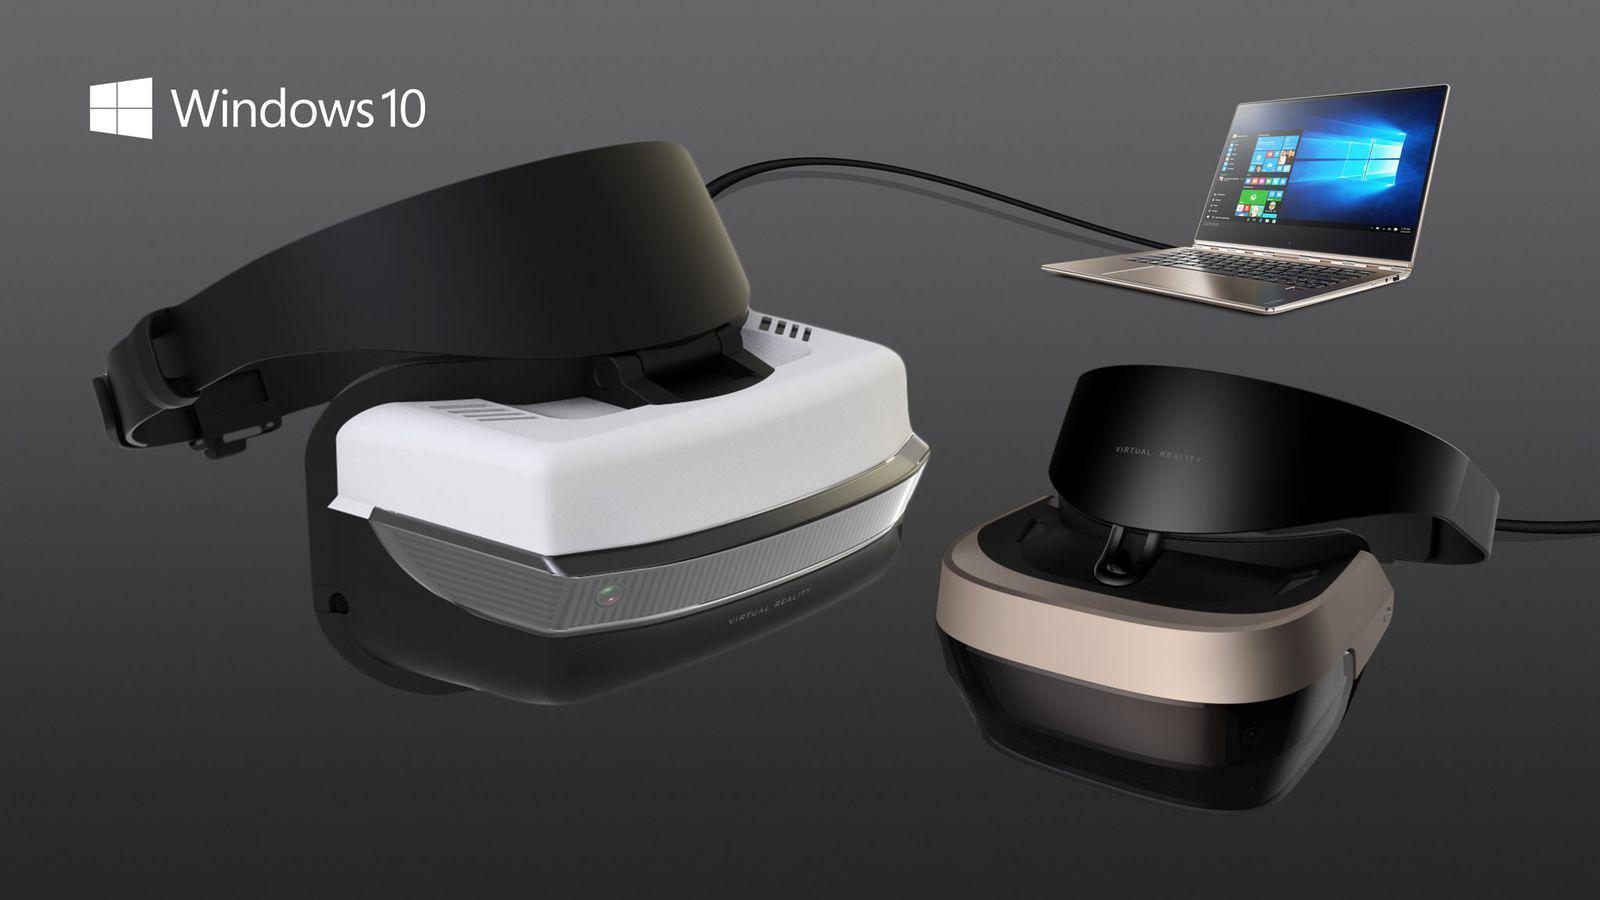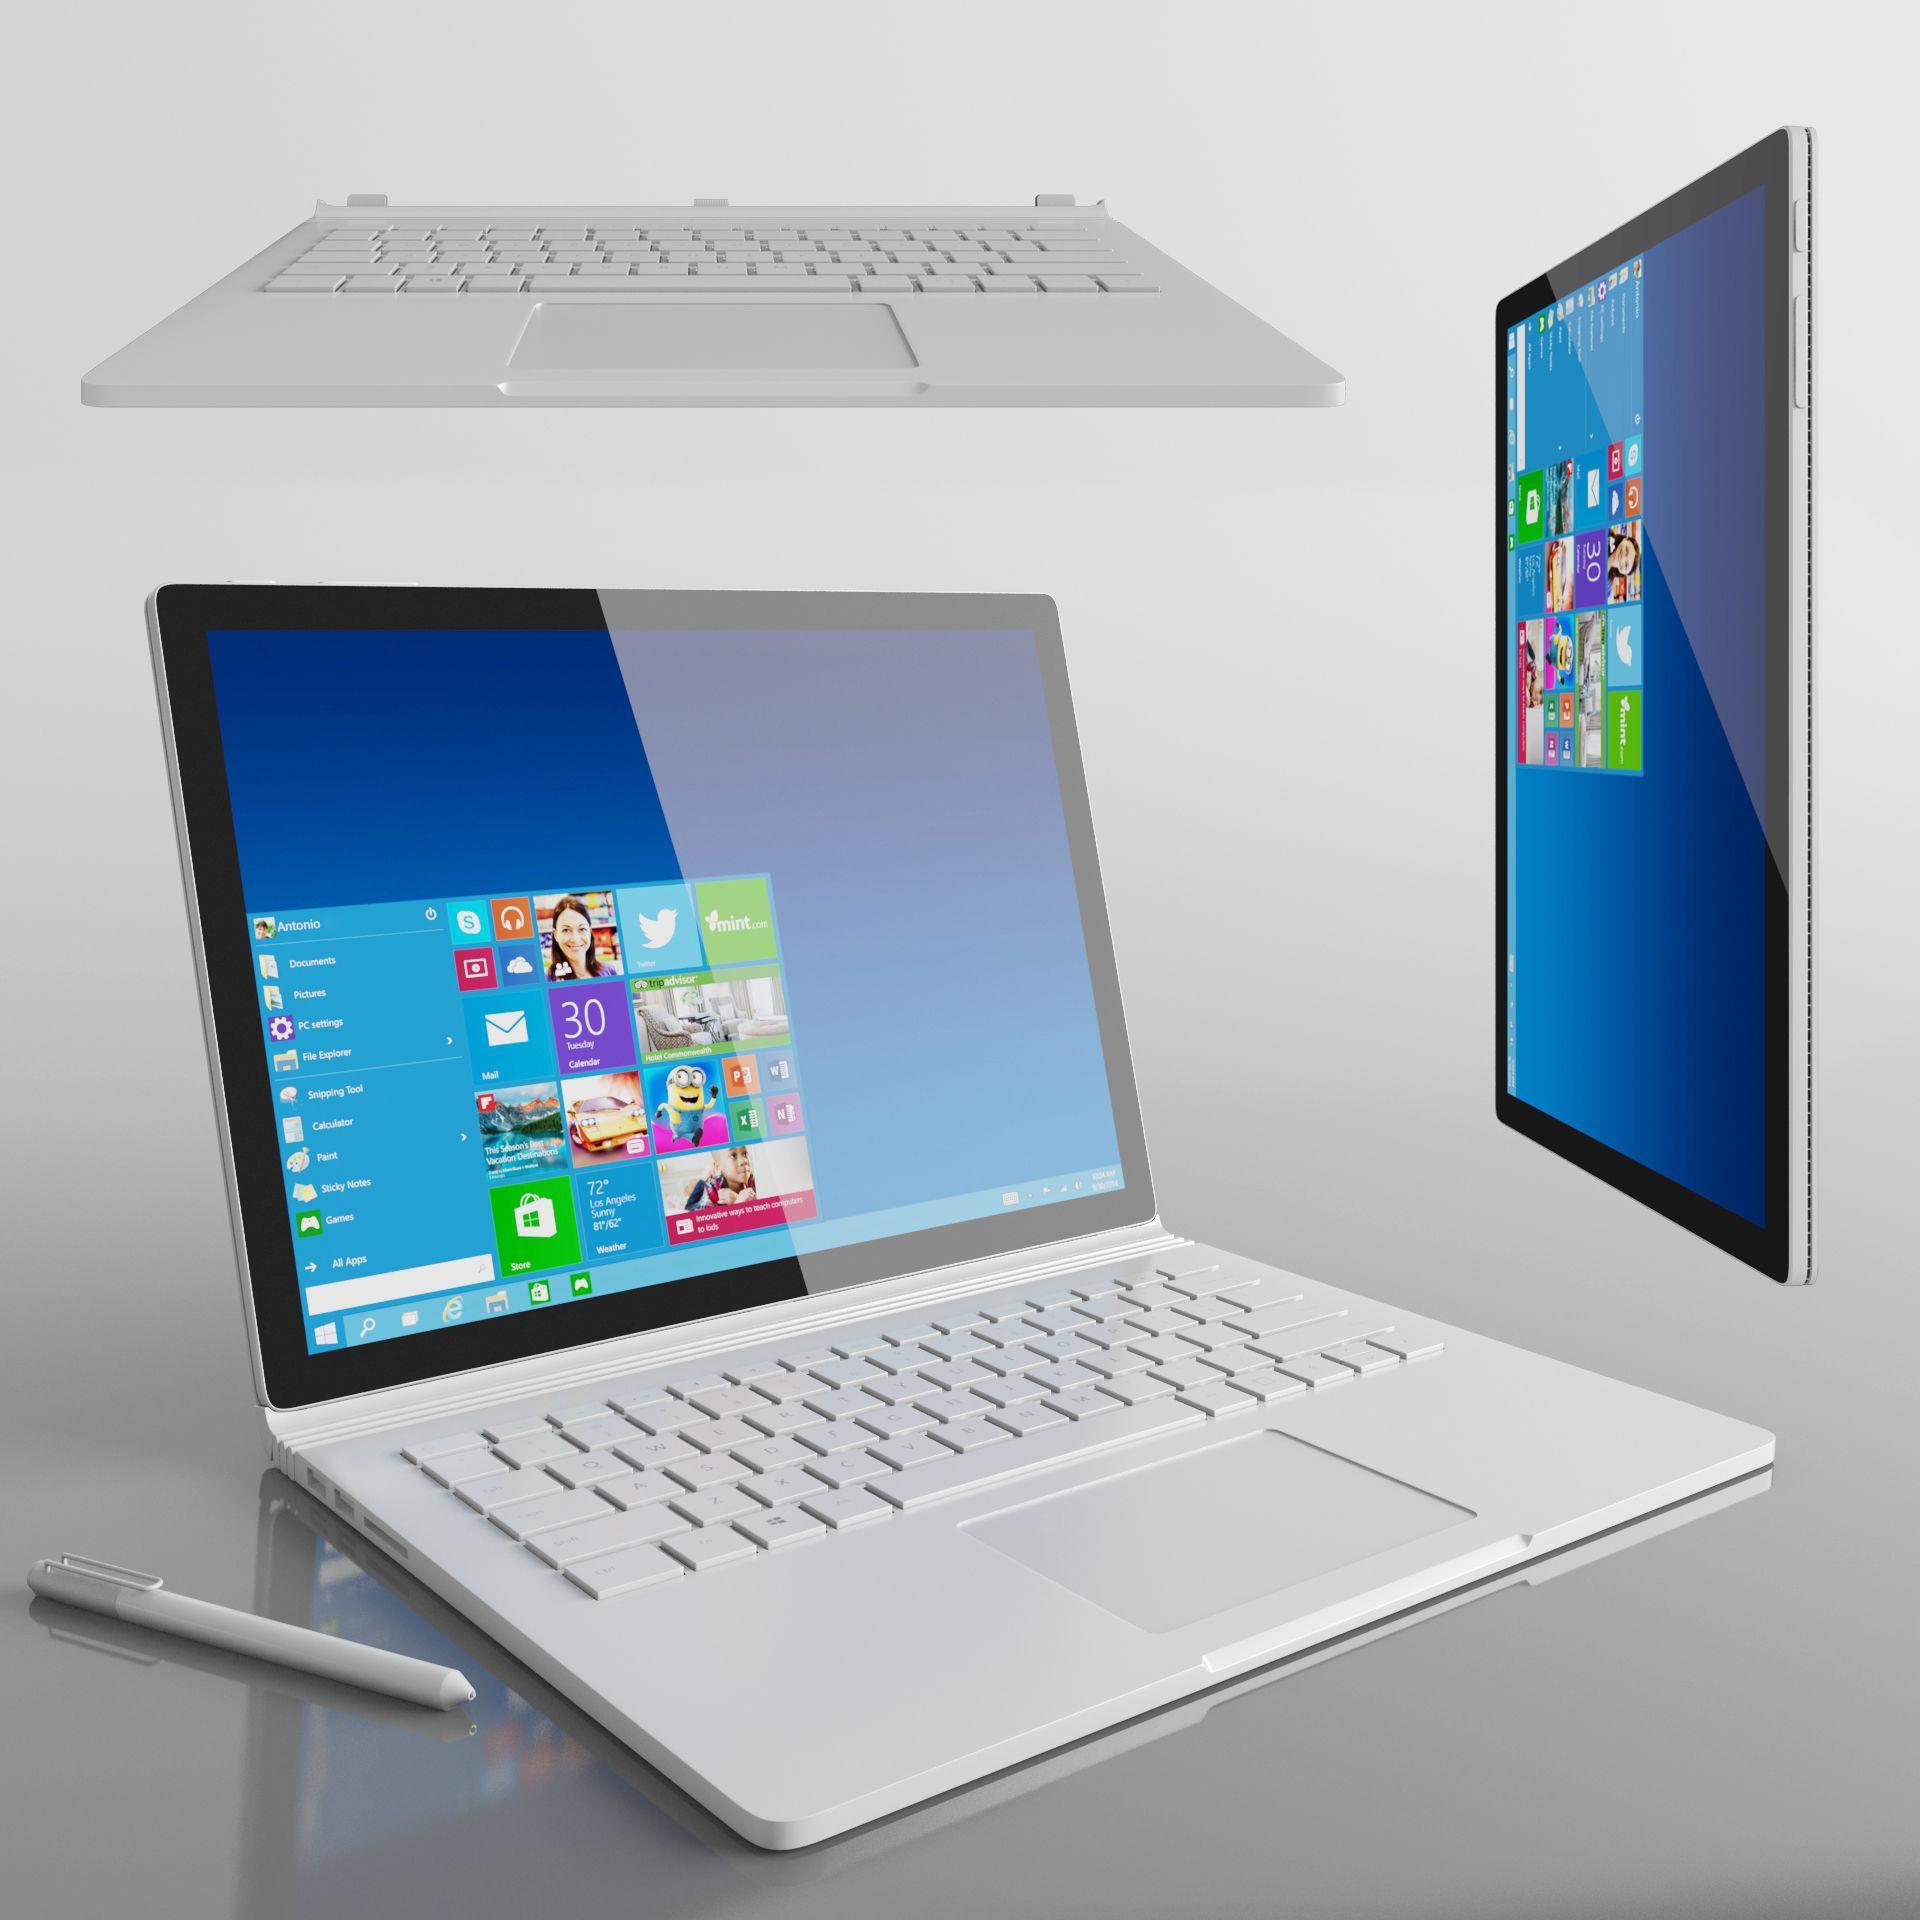The first image is the image on the left, the second image is the image on the right. Examine the images to the left and right. Is the description "One image shows an open laptop angled facing leftward, and the other image includes a head-on aerial view of an open laptop." accurate? Answer yes or no. No. The first image is the image on the left, the second image is the image on the right. Analyze the images presented: Is the assertion "There are two screens in one of the images." valid? Answer yes or no. Yes. 